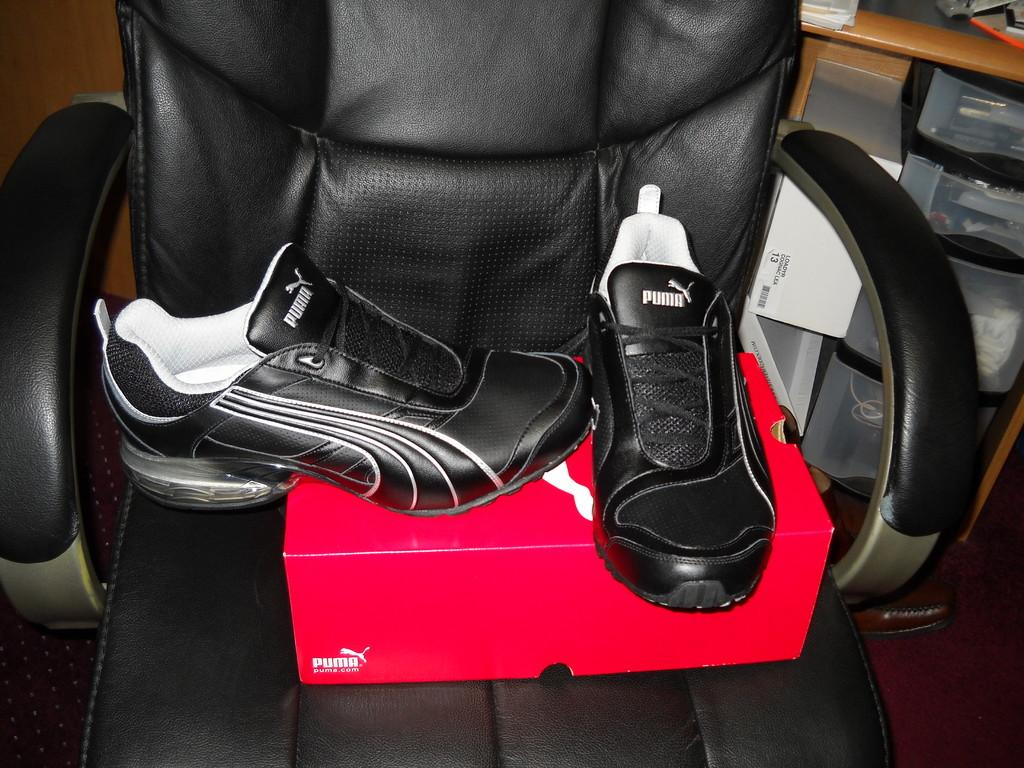What piece of furniture is present in the image? There is a chair in the image. What is placed on the chair? Shoes and a box are placed on the chair. What can be seen in the background of the image? There is a cupboard and a wall visible in the background of the image. What is inside the cupboard? The cupboard contains objects. What type of respect can be seen being shown to the shoes in the image? There is no indication of respect being shown to the shoes in the image; they are simply placed on the chair. What type of sticks are used to create the wall in the image? There is no mention of sticks being used to create the wall in the image; it is a solid wall. 